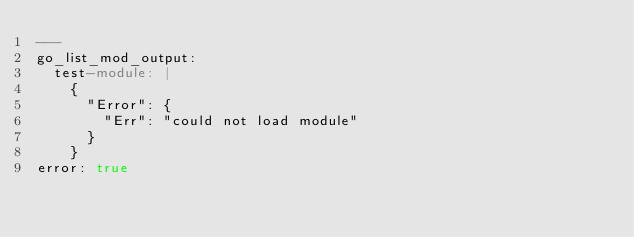<code> <loc_0><loc_0><loc_500><loc_500><_YAML_>---
go_list_mod_output:
  test-module: |
    {
      "Error": {
        "Err": "could not load module"
      }
    }
error: true
</code> 